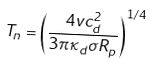Convert formula to latex. <formula><loc_0><loc_0><loc_500><loc_500>T _ { n } = \left ( \frac { 4 v c _ { d } ^ { 2 } } { 3 \pi \kappa _ { d } \sigma R _ { p } } \right ) ^ { 1 / 4 }</formula> 